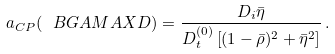Convert formula to latex. <formula><loc_0><loc_0><loc_500><loc_500>a _ { C P } ( \ B G A M A X D ) = \frac { D _ { i } \bar { \eta } } { D _ { t } ^ { ( 0 ) } \left [ ( 1 - \bar { \rho } ) ^ { 2 } + \bar { \eta } ^ { 2 } \right ] } \, .</formula> 